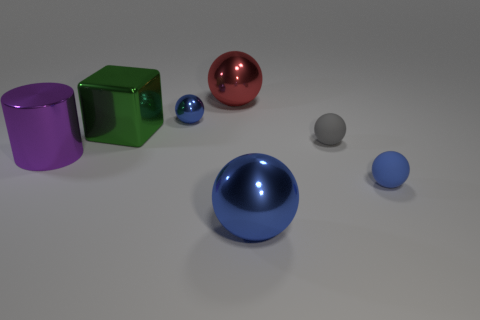How many objects are in the image, and can you describe them? There are five objects in the image: a purple metal cylinder, a green metal cube, a blue glass sphere, a red metal sphere, and a small grey plastic sphere. What do the different materials of the objects suggest about their possible uses? The metal objects might be used in industrial or decorative contexts due to their durability and luster. The glass sphere could serve a decorative purpose, benefiting from its transparency and shine, while the plastic sphere could be a lightweight component in various applications. 